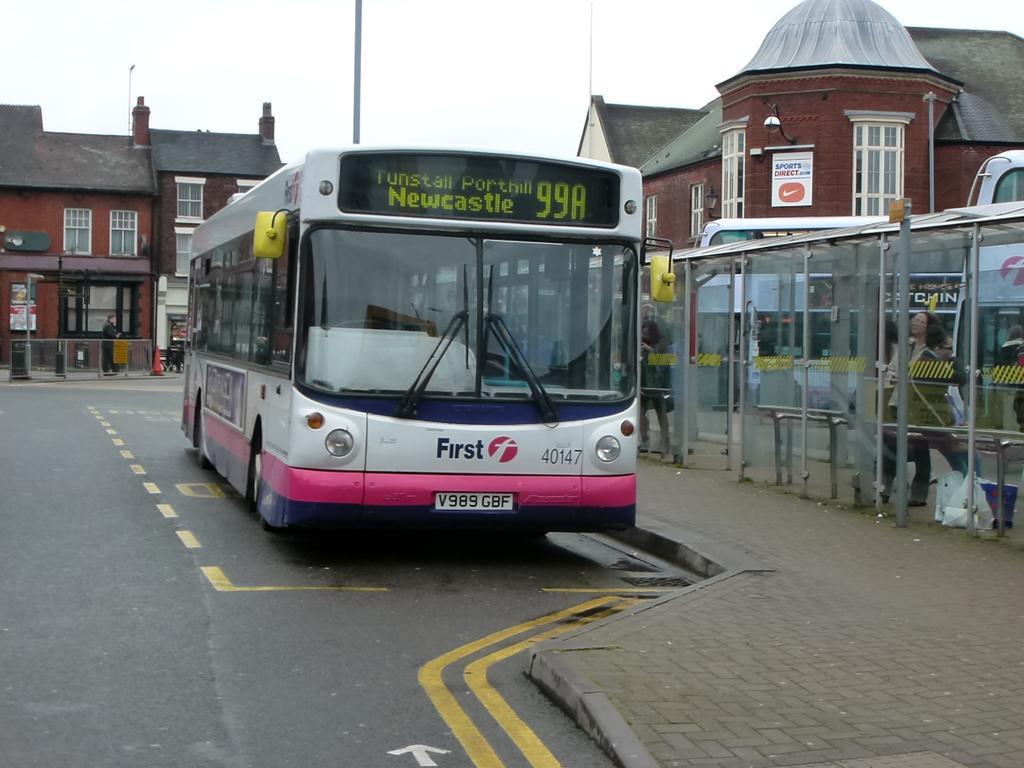How would you summarize this image in a sentence or two? In this image we can see the bus on the road. We can also see the bus bay with glass doors and also women. In the background we can see the building, poles, text board and also a person. Sky is also visible. We can also see the path. 